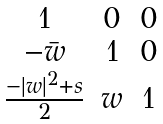<formula> <loc_0><loc_0><loc_500><loc_500>\begin{matrix} 1 & 0 & 0 \\ - \bar { w } & 1 & 0 \\ \frac { - | w | ^ { 2 } + s } { 2 } & w & 1 \end{matrix}</formula> 